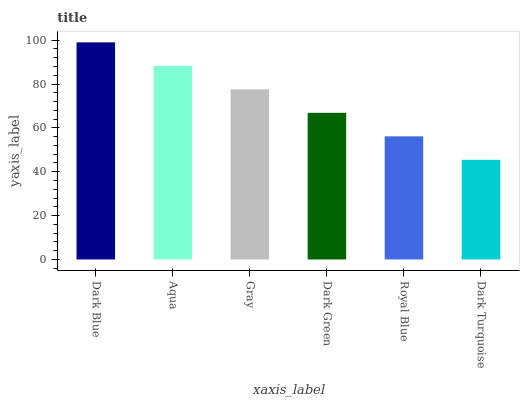Is Dark Turquoise the minimum?
Answer yes or no. Yes. Is Dark Blue the maximum?
Answer yes or no. Yes. Is Aqua the minimum?
Answer yes or no. No. Is Aqua the maximum?
Answer yes or no. No. Is Dark Blue greater than Aqua?
Answer yes or no. Yes. Is Aqua less than Dark Blue?
Answer yes or no. Yes. Is Aqua greater than Dark Blue?
Answer yes or no. No. Is Dark Blue less than Aqua?
Answer yes or no. No. Is Gray the high median?
Answer yes or no. Yes. Is Dark Green the low median?
Answer yes or no. Yes. Is Dark Blue the high median?
Answer yes or no. No. Is Dark Blue the low median?
Answer yes or no. No. 